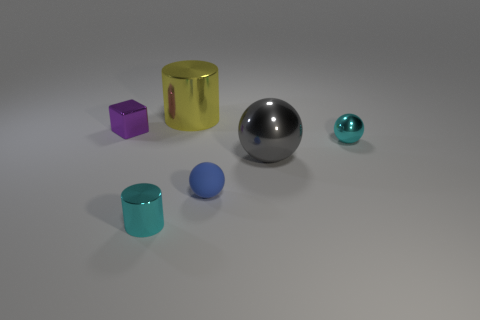Are there any other things that are made of the same material as the tiny blue object?
Provide a short and direct response. No. Is the cylinder left of the large yellow object made of the same material as the yellow object?
Ensure brevity in your answer.  Yes. There is a object that is left of the small matte object and in front of the big sphere; what shape is it?
Make the answer very short. Cylinder. Are there any tiny cyan balls left of the tiny metal thing that is right of the blue rubber thing?
Make the answer very short. No. What number of other objects are there of the same material as the cyan cylinder?
Ensure brevity in your answer.  4. There is a cyan metal thing on the right side of the blue rubber ball; does it have the same shape as the large shiny thing in front of the tiny cube?
Keep it short and to the point. Yes. Is the big cylinder made of the same material as the purple thing?
Make the answer very short. Yes. What size is the cylinder that is to the right of the small cyan thing that is to the left of the thing behind the small cube?
Give a very brief answer. Large. How many other things are there of the same color as the small rubber object?
Offer a very short reply. 0. What shape is the cyan metal object that is the same size as the cyan sphere?
Your answer should be compact. Cylinder. 